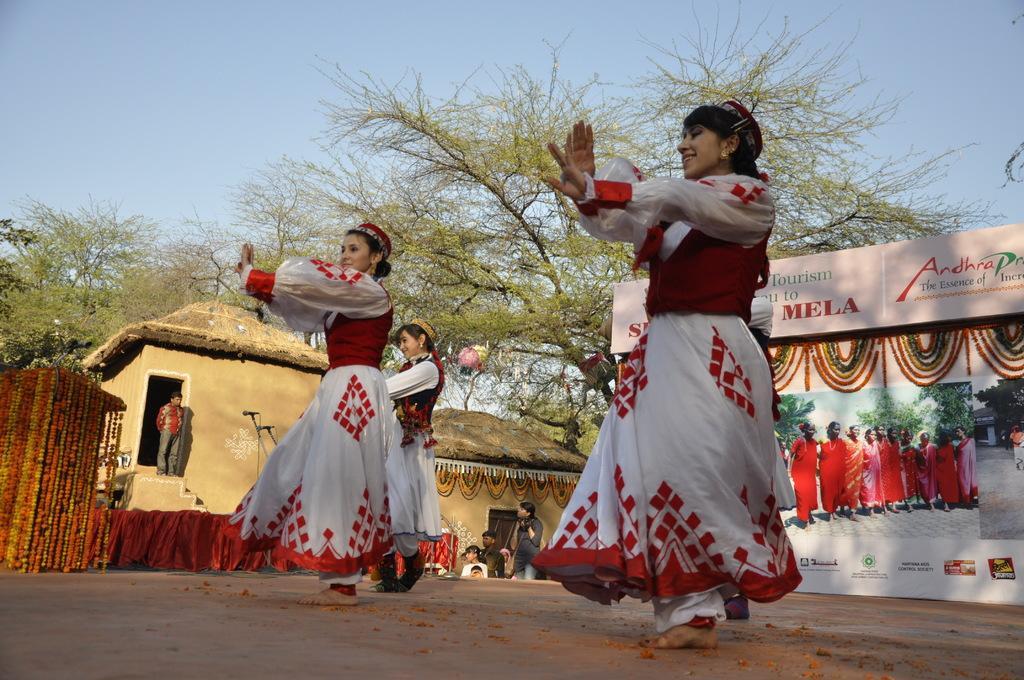How would you summarize this image in a sentence or two? In this image, we can see three persons wearing clothes and dancing on the ground. There is a banner on the right side of the image. There are some trees and huts in the middle of the image. In the background of the image, there is a sky. 